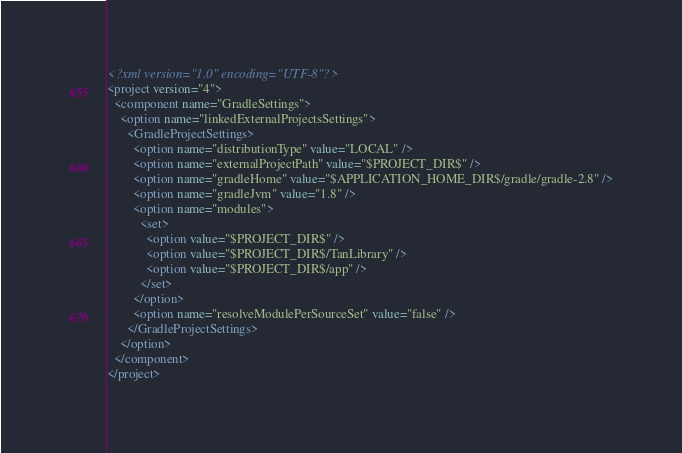Convert code to text. <code><loc_0><loc_0><loc_500><loc_500><_XML_><?xml version="1.0" encoding="UTF-8"?>
<project version="4">
  <component name="GradleSettings">
    <option name="linkedExternalProjectsSettings">
      <GradleProjectSettings>
        <option name="distributionType" value="LOCAL" />
        <option name="externalProjectPath" value="$PROJECT_DIR$" />
        <option name="gradleHome" value="$APPLICATION_HOME_DIR$/gradle/gradle-2.8" />
        <option name="gradleJvm" value="1.8" />
        <option name="modules">
          <set>
            <option value="$PROJECT_DIR$" />
            <option value="$PROJECT_DIR$/TanLibrary" />
            <option value="$PROJECT_DIR$/app" />
          </set>
        </option>
        <option name="resolveModulePerSourceSet" value="false" />
      </GradleProjectSettings>
    </option>
  </component>
</project></code> 